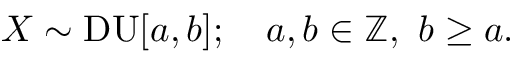Convert formula to latex. <formula><loc_0><loc_0><loc_500><loc_500>X \sim D U [ a , b ] ; \quad a , b \in \mathbb { Z } , \ b \geq a .</formula> 